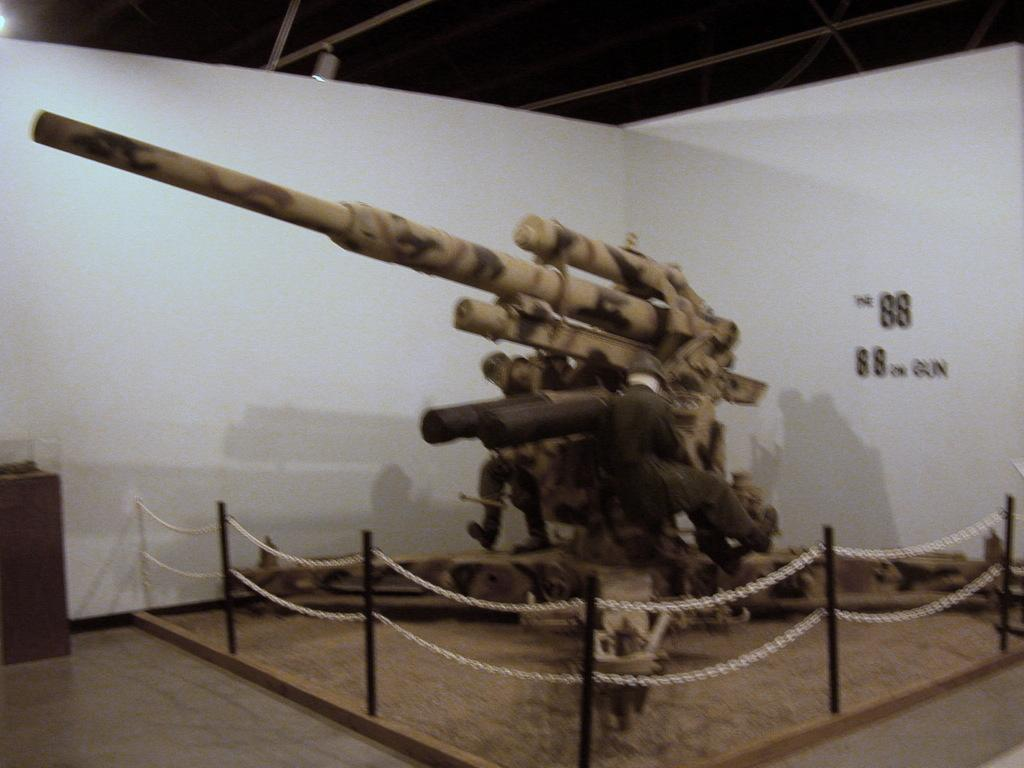How many people are in the image? There are two people in the image. What is located between the two people? A gun is visible between the two people. What type of objects can be seen in the image with chains? There are chains with poles in the image. What can be seen under the people's feet in the image? The floor is visible in the image. What is the object in the image? There is an object in the image, but its description is not provided in the facts. What is written on the wall in the image? There is text on a wall in the image. What is the source of light visible at the top of the image? There is a light visible at the top of the image. What type of owl can be seen in the image? There is no owl present in the image. What does the text on the wall say about hate? The facts do not mention any text related to hate, and the text on the wall is not described. 